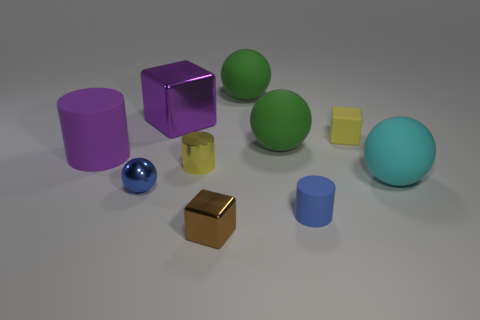Subtract all cylinders. How many objects are left? 7 Subtract 0 green cylinders. How many objects are left? 10 Subtract all tiny cylinders. Subtract all small brown shiny things. How many objects are left? 7 Add 3 large purple metallic objects. How many large purple metallic objects are left? 4 Add 7 tiny brown cubes. How many tiny brown cubes exist? 8 